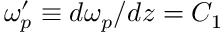Convert formula to latex. <formula><loc_0><loc_0><loc_500><loc_500>\omega _ { p } ^ { \prime } \equiv d \omega _ { p } / d z = C _ { 1 }</formula> 